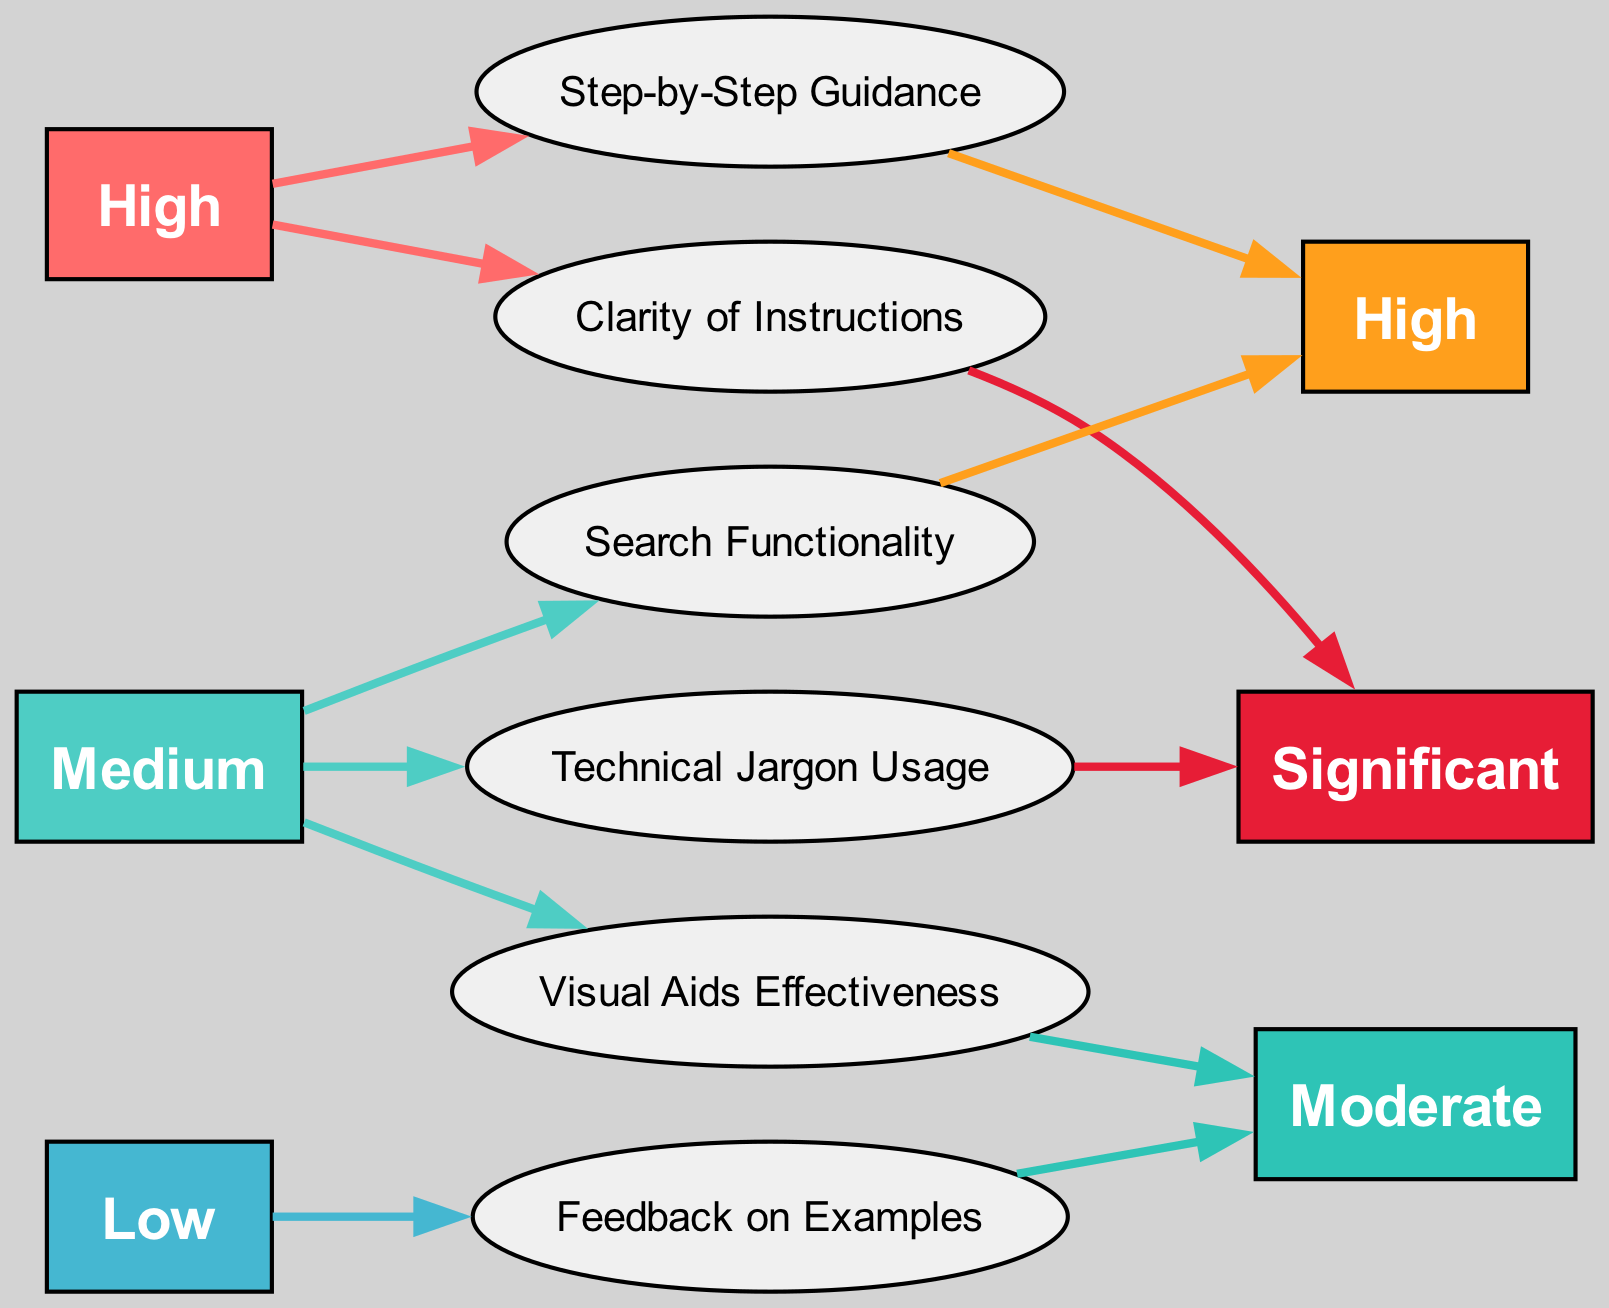What feedback theme has a high prevalence and significant impact? By looking at the nodes representing feedback themes, we can identify "Clarity of Instructions" which is categorized under high prevalence and significant impact.
Answer: Clarity of Instructions How many themes are categorized as having high prevalence? Counting the themes that have "High" under prevalence, we find "Clarity of Instructions" and "Step-by-Step Guidance," which totals to two themes.
Answer: 2 Which theme has the lowest prevalence? The theme "Feedback on Examples" has the lowest prevalence as denoted by the "Low" label.
Answer: Feedback on Examples What is the main impact of the "Search Functionality" theme? Following the edges from the "Search Functionality" node, it leads to the "High" impact, indicating that it has a significant effect on user manual updates.
Answer: High Which prevalence category has the most themes connected to it? Observing the connections in the diagram, the "Medium" prevalence category has three themes linked: "Visual Aids Effectiveness," "Technical Jargon Usage," and "Search Functionality."
Answer: Medium What is the color associated with significant impact? By referencing the impact categories in the diagram, the color used for "Significant" impact is dark red (#E71D36).
Answer: Dark red Which feedback theme shows moderate impact and low prevalence? Looking through the themes, "Feedback on Examples" is the one that shows a moderate impact while being classified under low prevalence.
Answer: Feedback on Examples Which node has the highest number of edges coming from it? Analyzing the connections, the "High" prevalence category has the highest number of edges leading to two themes: "Clarity of Instructions" and "Step-by-Step Guidance." Therefore, it's the "High" prevalence node that connects to the most themes.
Answer: High What is the connection between "Visual Aids Effectiveness" and its impact? Following the theme "Visual Aids Effectiveness," we see it has a "Moderate" impact as represented by the connection to the respective impact node.
Answer: Moderate 